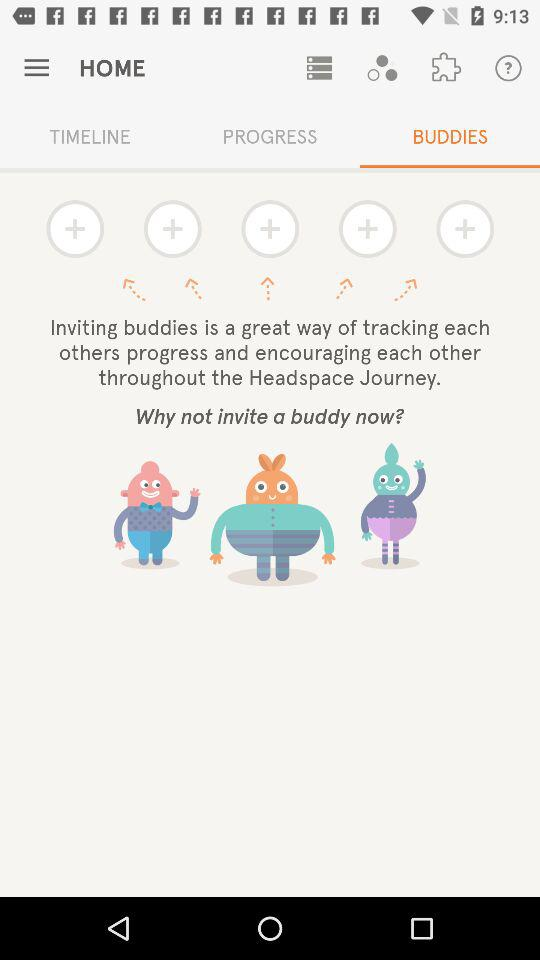Which category of "HOME" am I in? You are in the "BUDDIES" category of "HOME". 